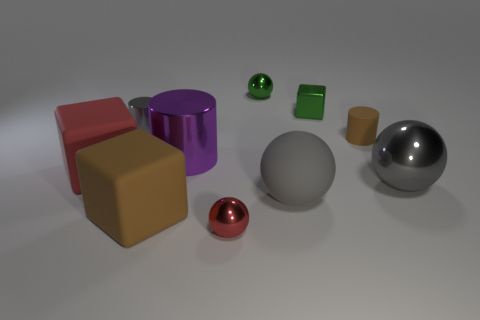Subtract all cubes. How many objects are left? 7 Subtract all green cubes. How many cubes are left? 2 Subtract all brown rubber cylinders. How many cylinders are left? 2 Subtract 1 brown blocks. How many objects are left? 9 Subtract 2 cylinders. How many cylinders are left? 1 Subtract all blue balls. Subtract all blue cylinders. How many balls are left? 4 Subtract all green spheres. How many cyan blocks are left? 0 Subtract all gray balls. Subtract all tiny rubber objects. How many objects are left? 7 Add 6 small red metal spheres. How many small red metal spheres are left? 7 Add 1 large red things. How many large red things exist? 2 